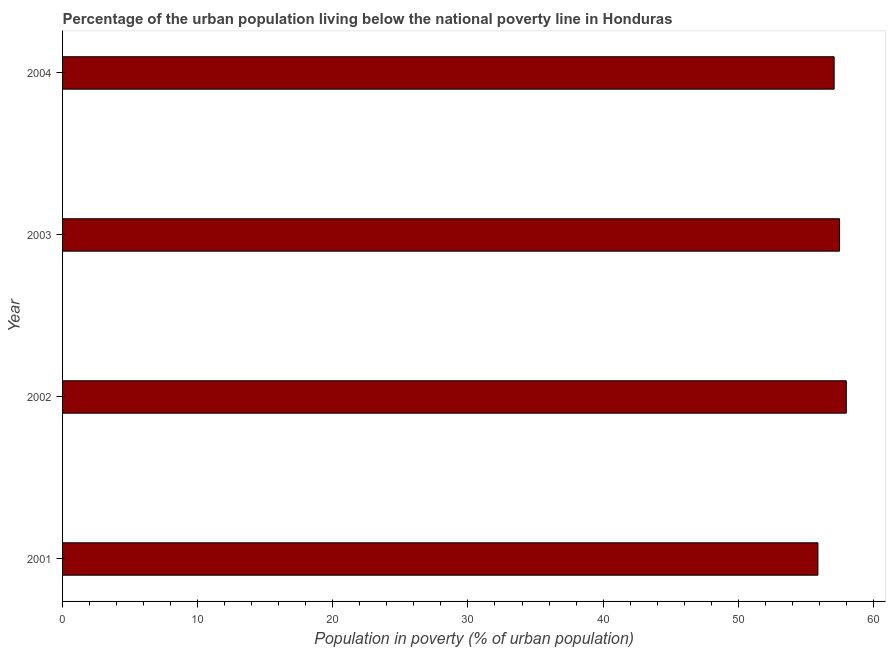Does the graph contain any zero values?
Keep it short and to the point. No. What is the title of the graph?
Offer a very short reply. Percentage of the urban population living below the national poverty line in Honduras. What is the label or title of the X-axis?
Ensure brevity in your answer.  Population in poverty (% of urban population). What is the percentage of urban population living below poverty line in 2001?
Offer a terse response. 55.9. Across all years, what is the minimum percentage of urban population living below poverty line?
Ensure brevity in your answer.  55.9. In which year was the percentage of urban population living below poverty line maximum?
Keep it short and to the point. 2002. In which year was the percentage of urban population living below poverty line minimum?
Offer a very short reply. 2001. What is the sum of the percentage of urban population living below poverty line?
Make the answer very short. 228.5. What is the difference between the percentage of urban population living below poverty line in 2002 and 2004?
Your response must be concise. 0.9. What is the average percentage of urban population living below poverty line per year?
Offer a very short reply. 57.12. What is the median percentage of urban population living below poverty line?
Make the answer very short. 57.3. Is the difference between the percentage of urban population living below poverty line in 2002 and 2004 greater than the difference between any two years?
Give a very brief answer. No. What is the difference between the highest and the second highest percentage of urban population living below poverty line?
Offer a terse response. 0.5. Is the sum of the percentage of urban population living below poverty line in 2001 and 2004 greater than the maximum percentage of urban population living below poverty line across all years?
Keep it short and to the point. Yes. In how many years, is the percentage of urban population living below poverty line greater than the average percentage of urban population living below poverty line taken over all years?
Your answer should be very brief. 2. How many bars are there?
Provide a short and direct response. 4. How many years are there in the graph?
Provide a succinct answer. 4. Are the values on the major ticks of X-axis written in scientific E-notation?
Ensure brevity in your answer.  No. What is the Population in poverty (% of urban population) of 2001?
Offer a terse response. 55.9. What is the Population in poverty (% of urban population) of 2002?
Offer a very short reply. 58. What is the Population in poverty (% of urban population) in 2003?
Your answer should be very brief. 57.5. What is the Population in poverty (% of urban population) in 2004?
Provide a short and direct response. 57.1. What is the difference between the Population in poverty (% of urban population) in 2001 and 2003?
Provide a short and direct response. -1.6. What is the difference between the Population in poverty (% of urban population) in 2002 and 2003?
Give a very brief answer. 0.5. What is the difference between the Population in poverty (% of urban population) in 2003 and 2004?
Your answer should be compact. 0.4. What is the ratio of the Population in poverty (% of urban population) in 2001 to that in 2002?
Your answer should be compact. 0.96. What is the ratio of the Population in poverty (% of urban population) in 2001 to that in 2003?
Your response must be concise. 0.97. What is the ratio of the Population in poverty (% of urban population) in 2002 to that in 2003?
Your response must be concise. 1.01. 